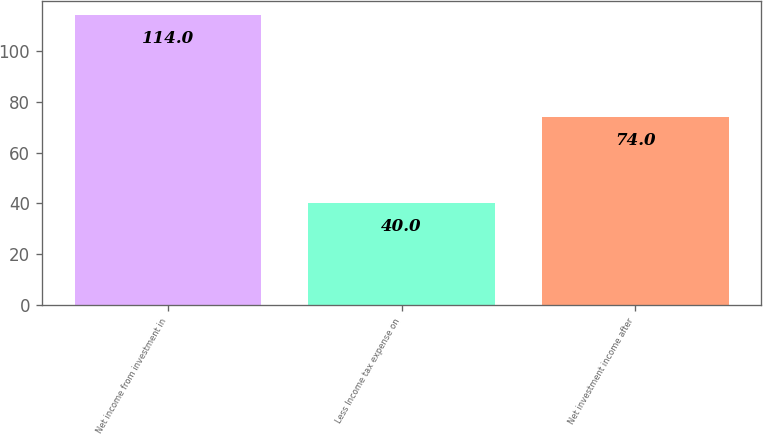Convert chart to OTSL. <chart><loc_0><loc_0><loc_500><loc_500><bar_chart><fcel>Net income from investment in<fcel>Less Income tax expense on<fcel>Net investment income after<nl><fcel>114<fcel>40<fcel>74<nl></chart> 